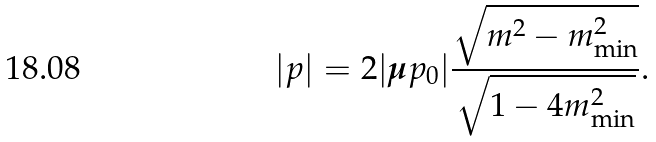<formula> <loc_0><loc_0><loc_500><loc_500>| { p } | = 2 | { \boldsymbol \mu } p _ { 0 } | \frac { \sqrt { m ^ { 2 } - m ^ { 2 } _ { \min } } } { \sqrt { 1 - 4 m _ { \min } ^ { 2 } } } .</formula> 